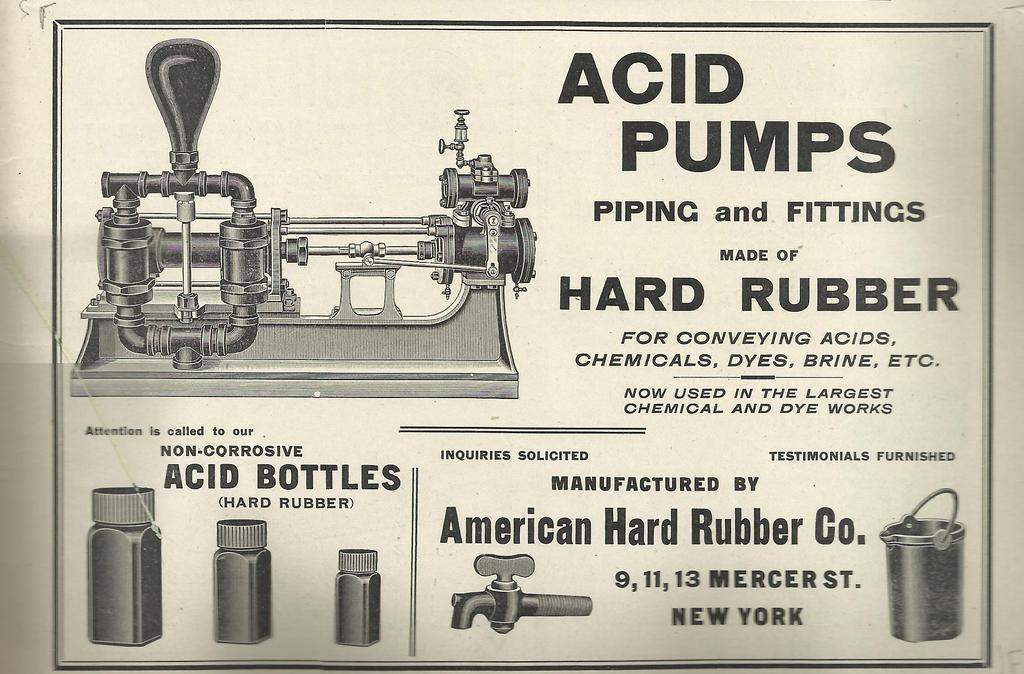<image>
Render a clear and concise summary of the photo. A sign is advertising 'Acid Pumps Piping and Fittings', made by the American Hard Rubber company. 